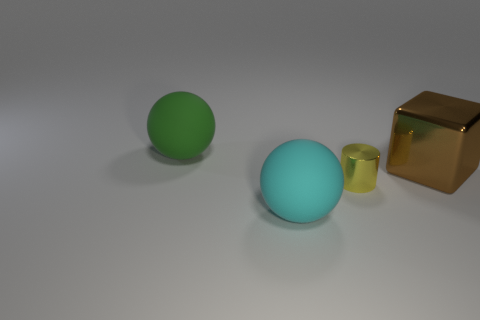Add 2 brown blocks. How many objects exist? 6 Subtract all cylinders. How many objects are left? 3 Add 1 tiny red rubber cylinders. How many tiny red rubber cylinders exist? 1 Subtract 1 green balls. How many objects are left? 3 Subtract all small blue metallic things. Subtract all matte balls. How many objects are left? 2 Add 1 metallic objects. How many metallic objects are left? 3 